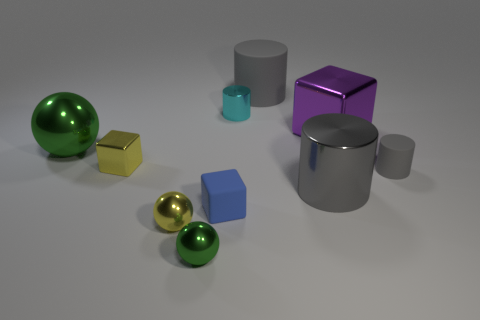Is the color of the big matte cylinder the same as the large shiny cylinder?
Offer a very short reply. Yes. Is there anything else that is the same material as the small yellow ball?
Your answer should be compact. Yes. Is the number of small cubes less than the number of tiny blue things?
Your answer should be compact. No. There is a small cyan cylinder; are there any large shiny spheres behind it?
Your answer should be compact. No. There is a metallic thing that is both on the right side of the tiny green object and in front of the small rubber cylinder; what shape is it?
Provide a short and direct response. Cylinder. Are there any rubber things of the same shape as the big green metal thing?
Your response must be concise. No. Is the size of the gray cylinder that is behind the cyan thing the same as the gray thing to the right of the purple block?
Offer a very short reply. No. Is the number of yellow metallic things greater than the number of large yellow matte cylinders?
Offer a terse response. Yes. How many yellow cylinders are made of the same material as the big purple block?
Your answer should be very brief. 0. Do the cyan thing and the big gray rubber thing have the same shape?
Make the answer very short. Yes. 